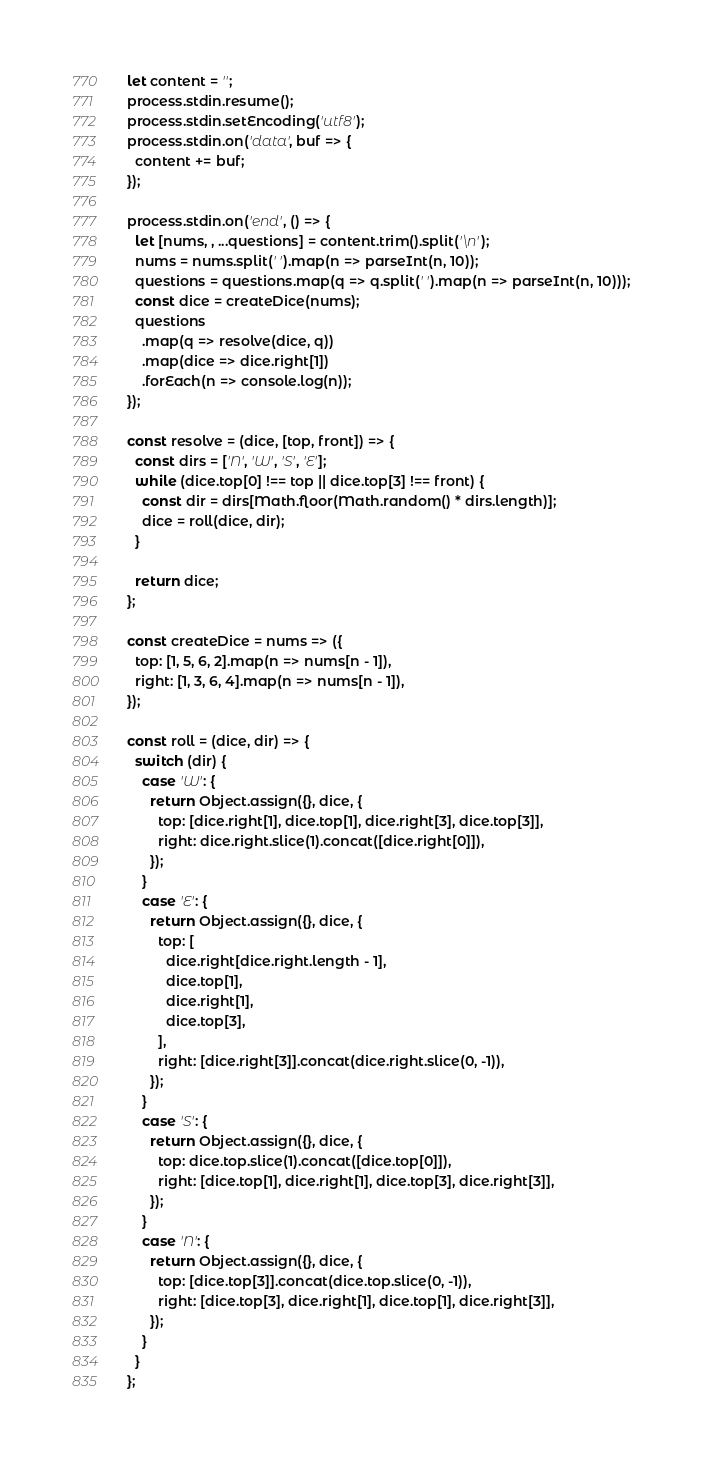Convert code to text. <code><loc_0><loc_0><loc_500><loc_500><_JavaScript_>let content = '';
process.stdin.resume();
process.stdin.setEncoding('utf8');
process.stdin.on('data', buf => {
  content += buf;
});

process.stdin.on('end', () => {
  let [nums, , ...questions] = content.trim().split('\n');
  nums = nums.split(' ').map(n => parseInt(n, 10));
  questions = questions.map(q => q.split(' ').map(n => parseInt(n, 10)));
  const dice = createDice(nums);
  questions
    .map(q => resolve(dice, q))
    .map(dice => dice.right[1])
    .forEach(n => console.log(n));
});

const resolve = (dice, [top, front]) => {
  const dirs = ['N', 'W', 'S', 'E'];
  while (dice.top[0] !== top || dice.top[3] !== front) {
    const dir = dirs[Math.floor(Math.random() * dirs.length)];
    dice = roll(dice, dir);
  }

  return dice;
};

const createDice = nums => ({
  top: [1, 5, 6, 2].map(n => nums[n - 1]),
  right: [1, 3, 6, 4].map(n => nums[n - 1]),
});

const roll = (dice, dir) => {
  switch (dir) {
    case 'W': {
      return Object.assign({}, dice, {
        top: [dice.right[1], dice.top[1], dice.right[3], dice.top[3]],
        right: dice.right.slice(1).concat([dice.right[0]]),
      });
    }
    case 'E': {
      return Object.assign({}, dice, {
        top: [
          dice.right[dice.right.length - 1],
          dice.top[1],
          dice.right[1],
          dice.top[3],
        ],
        right: [dice.right[3]].concat(dice.right.slice(0, -1)),
      });
    }
    case 'S': {
      return Object.assign({}, dice, {
        top: dice.top.slice(1).concat([dice.top[0]]),
        right: [dice.top[1], dice.right[1], dice.top[3], dice.right[3]],
      });
    }
    case 'N': {
      return Object.assign({}, dice, {
        top: [dice.top[3]].concat(dice.top.slice(0, -1)),
        right: [dice.top[3], dice.right[1], dice.top[1], dice.right[3]],
      });
    }
  }
};
</code> 